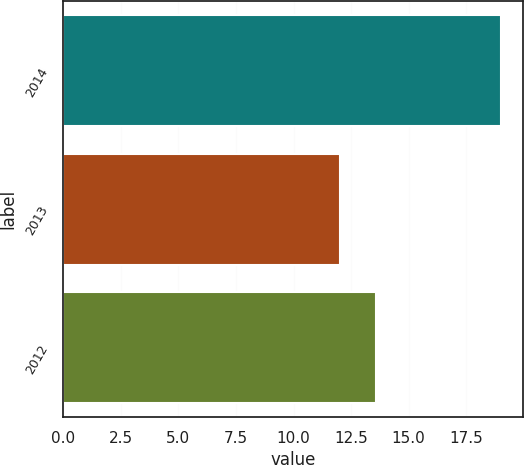Convert chart. <chart><loc_0><loc_0><loc_500><loc_500><bar_chart><fcel>2014<fcel>2013<fcel>2012<nl><fcel>19<fcel>12<fcel>13.6<nl></chart> 